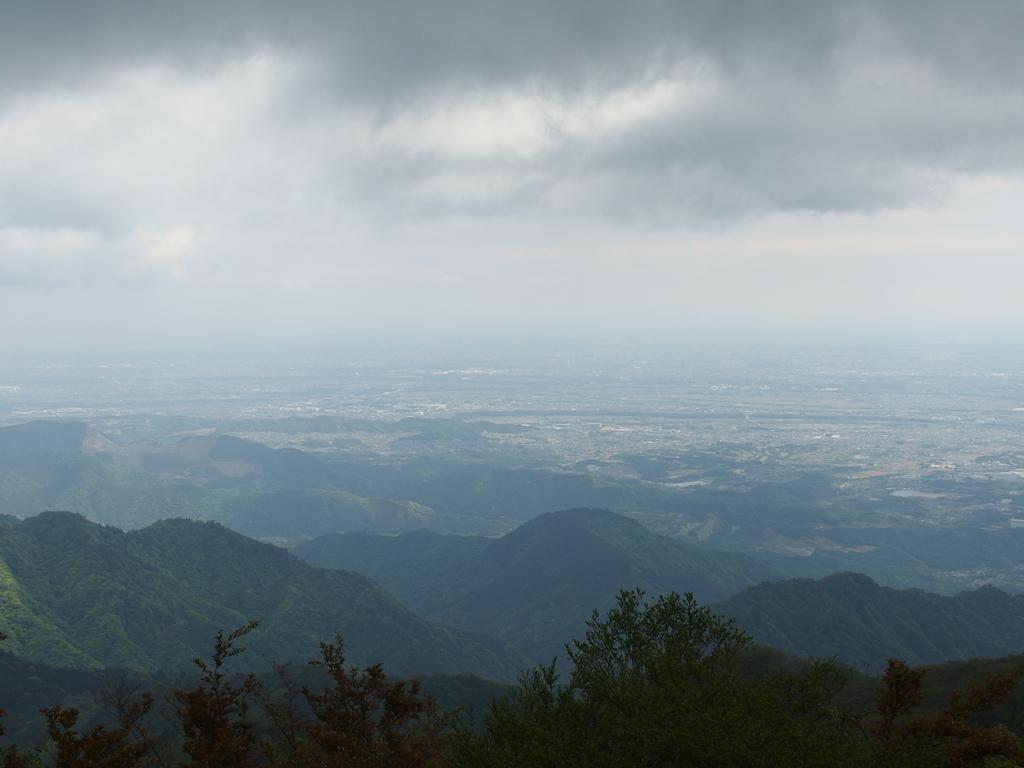Please provide a concise description of this image. In this image we can see sky with clouds, ground, hills and trees. 